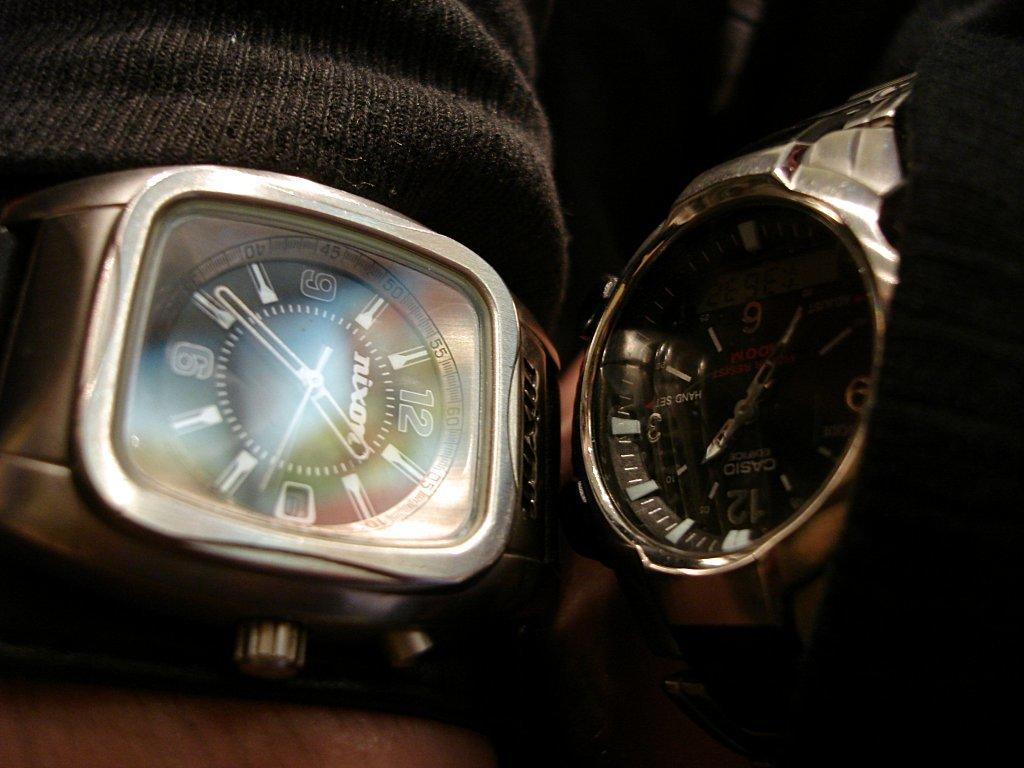Provide a one-sentence caption for the provided image. Two watches next to each other and the square faced one is a nixon. 